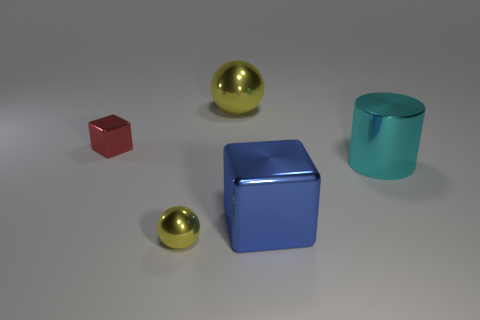What is the color of the tiny metallic object that is in front of the red object?
Ensure brevity in your answer.  Yellow. There is a yellow thing that is the same size as the cyan shiny thing; what shape is it?
Offer a very short reply. Sphere. There is a large cyan metal thing; what number of tiny yellow balls are to the right of it?
Ensure brevity in your answer.  0. What number of things are small matte blocks or blue metal cubes?
Give a very brief answer. 1. There is a big thing that is to the left of the cyan metal thing and behind the blue cube; what is its shape?
Give a very brief answer. Sphere. How many small red shiny cubes are there?
Your answer should be very brief. 1. What color is the big cube that is made of the same material as the cylinder?
Provide a succinct answer. Blue. Are there more blue blocks than yellow objects?
Your answer should be compact. No. There is a metal object that is behind the blue metal cube and on the left side of the big metal ball; what size is it?
Make the answer very short. Small. What material is the other ball that is the same color as the small ball?
Your answer should be very brief. Metal. 